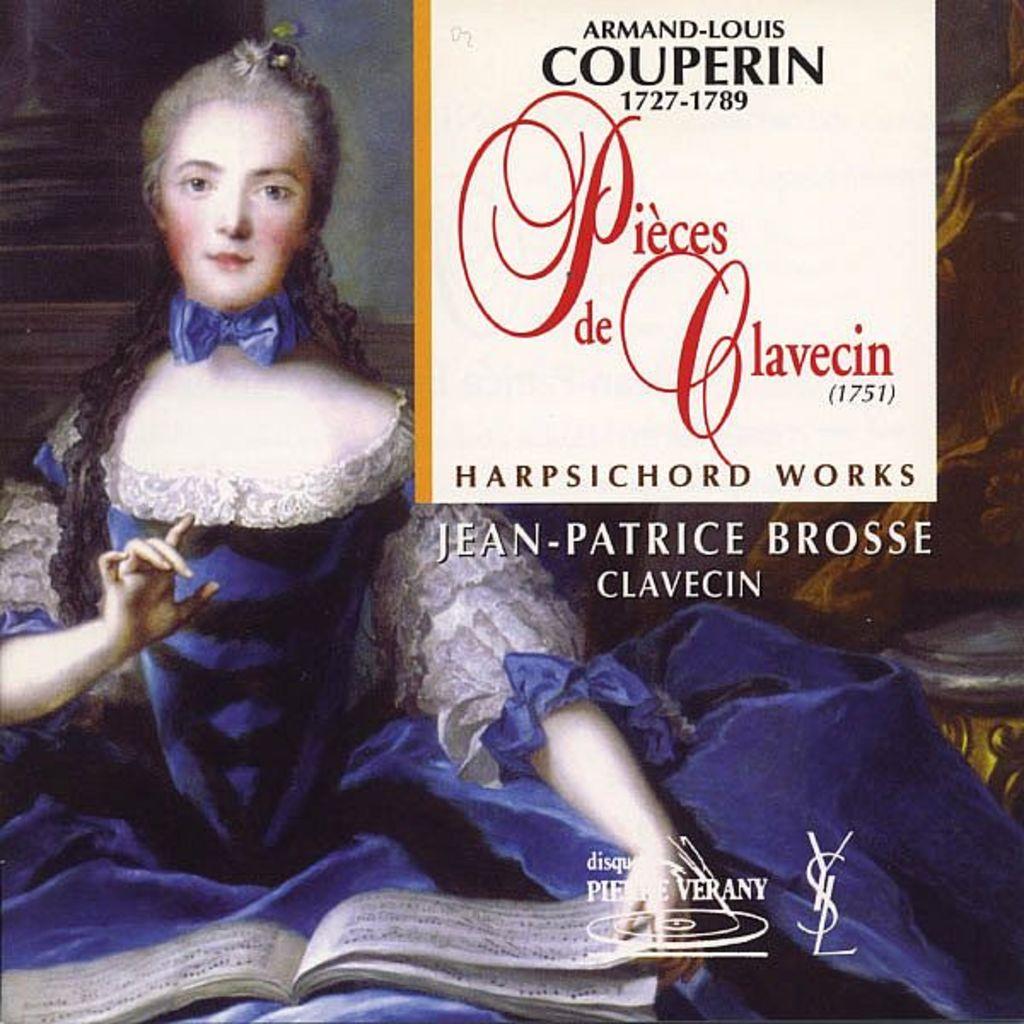What is the name of this book?
Give a very brief answer. Pieces de clavecin. 